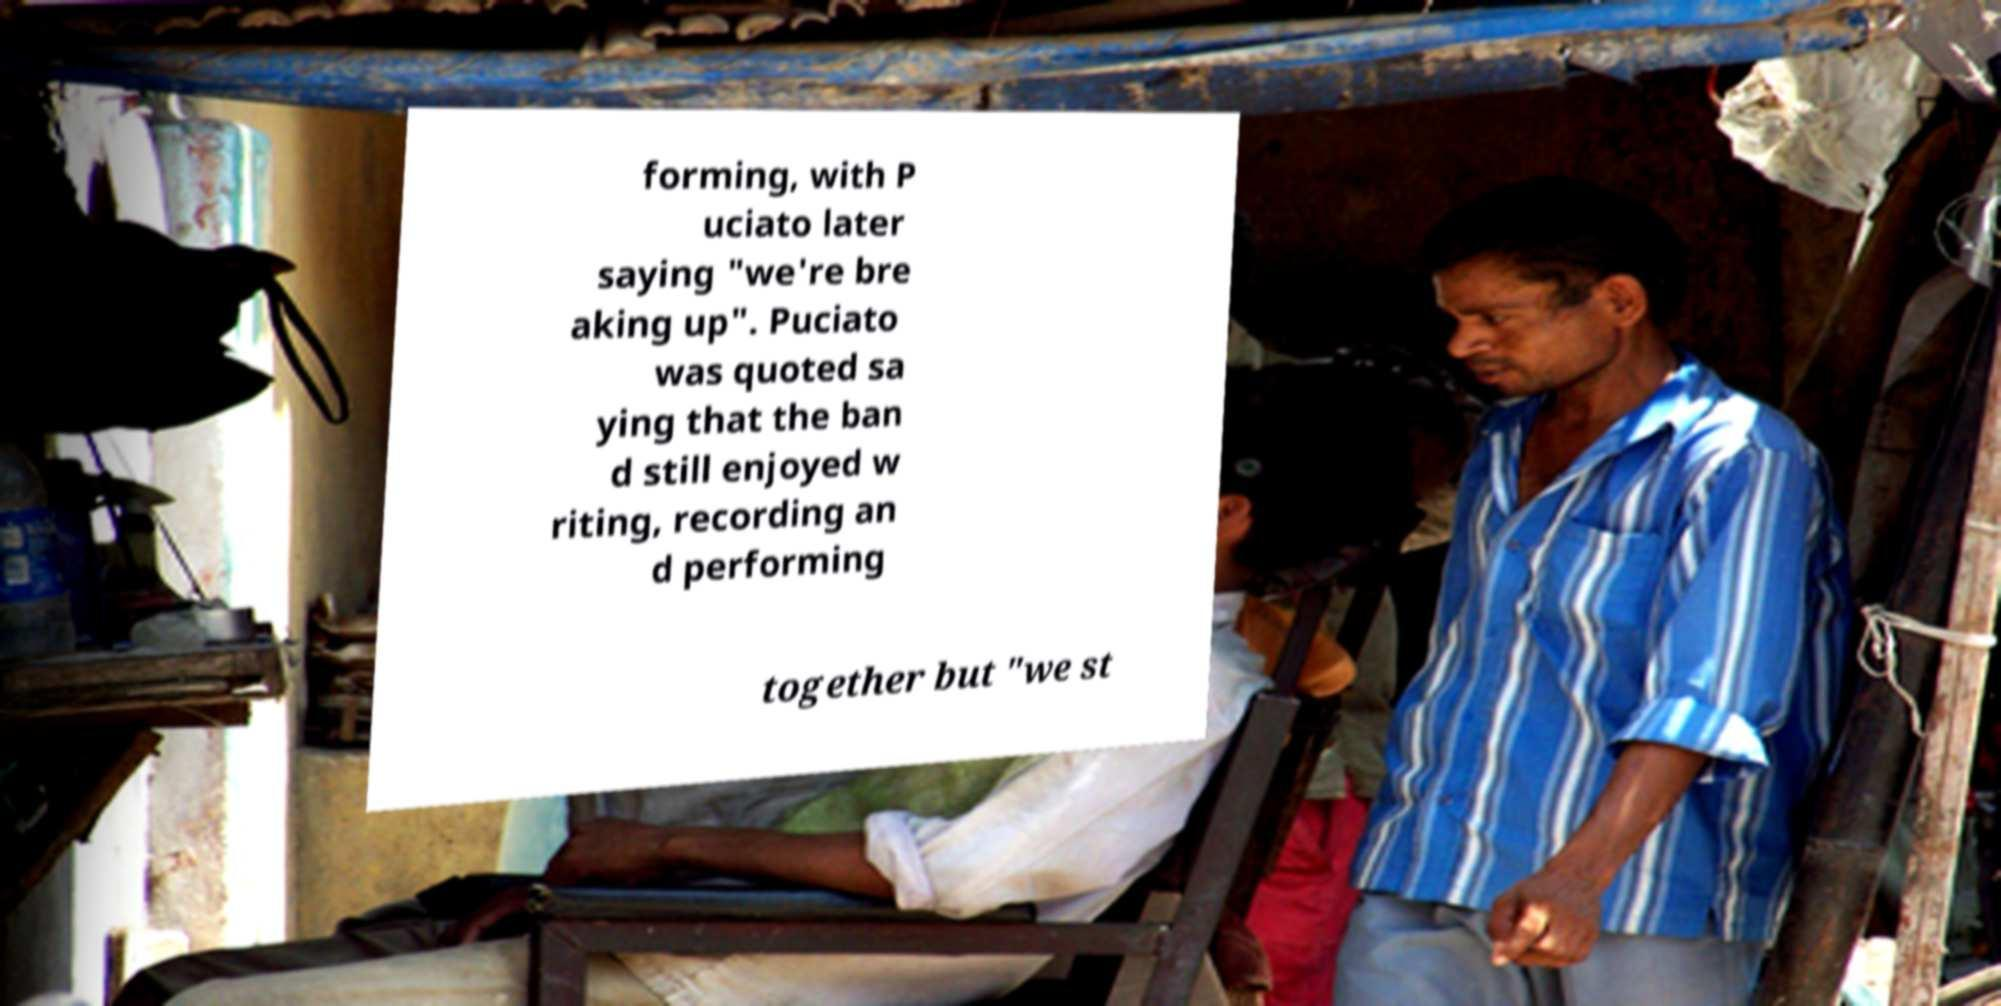I need the written content from this picture converted into text. Can you do that? forming, with P uciato later saying "we're bre aking up". Puciato was quoted sa ying that the ban d still enjoyed w riting, recording an d performing together but "we st 